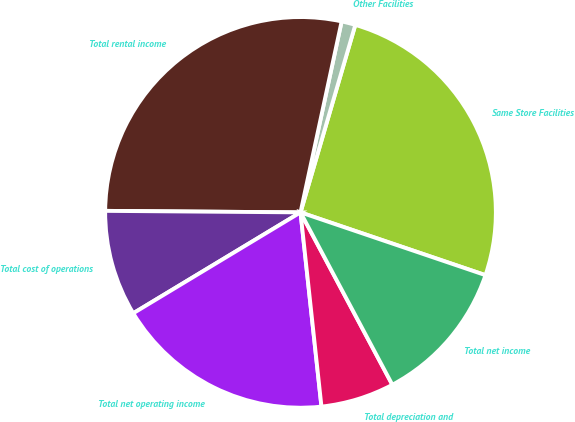<chart> <loc_0><loc_0><loc_500><loc_500><pie_chart><fcel>Same Store Facilities<fcel>Other Facilities<fcel>Total rental income<fcel>Total cost of operations<fcel>Total net operating income<fcel>Total depreciation and<fcel>Total net income<nl><fcel>25.68%<fcel>1.15%<fcel>28.25%<fcel>8.76%<fcel>18.07%<fcel>6.08%<fcel>12.0%<nl></chart> 